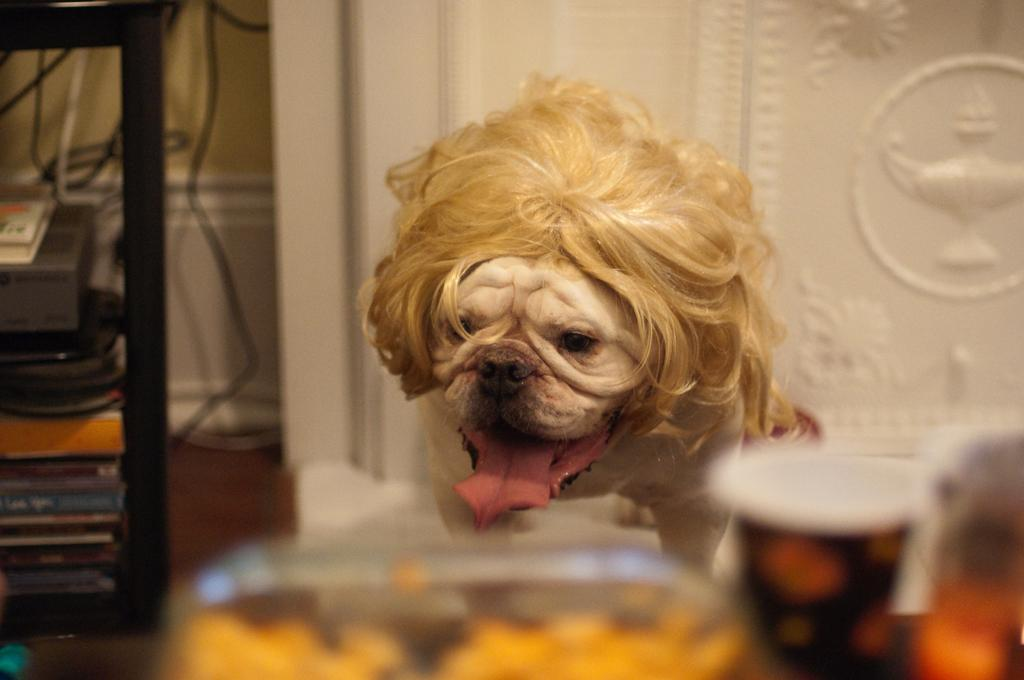What type of animal can be seen in the image? There is a dog in the image. What is the glass used for in the image? The purpose of the glass is not clear from the image, but it is present. What is the device in the image? The image shows a device, but its specific function is not clear. What are the cables connected to in the image? The cables are present in the image, but their connection points are not visible. Can you describe any other objects in the image? There are other objects in the image, but their specific details are not clear. What can be seen in the background of the image? There is a wall in the background of the image. Where is the notebook in the image? There is no notebook present in the image. What type of bird can be seen flying in the image? There are no birds visible in the image. 